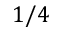Convert formula to latex. <formula><loc_0><loc_0><loc_500><loc_500>1 / 4</formula> 